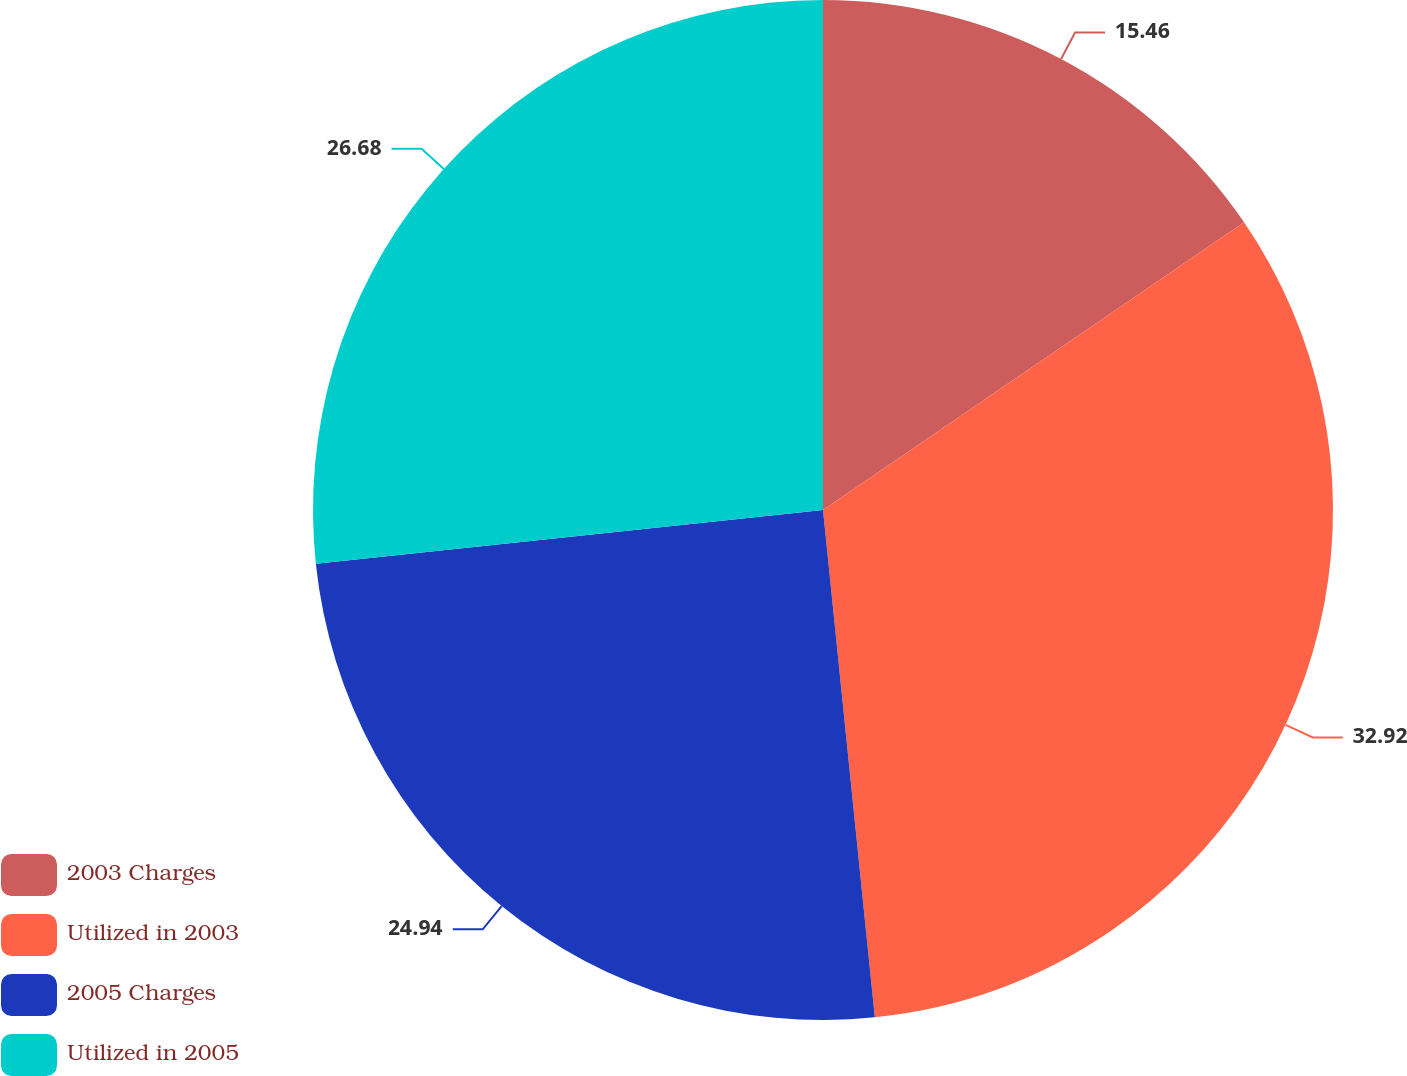<chart> <loc_0><loc_0><loc_500><loc_500><pie_chart><fcel>2003 Charges<fcel>Utilized in 2003<fcel>2005 Charges<fcel>Utilized in 2005<nl><fcel>15.46%<fcel>32.92%<fcel>24.94%<fcel>26.68%<nl></chart> 